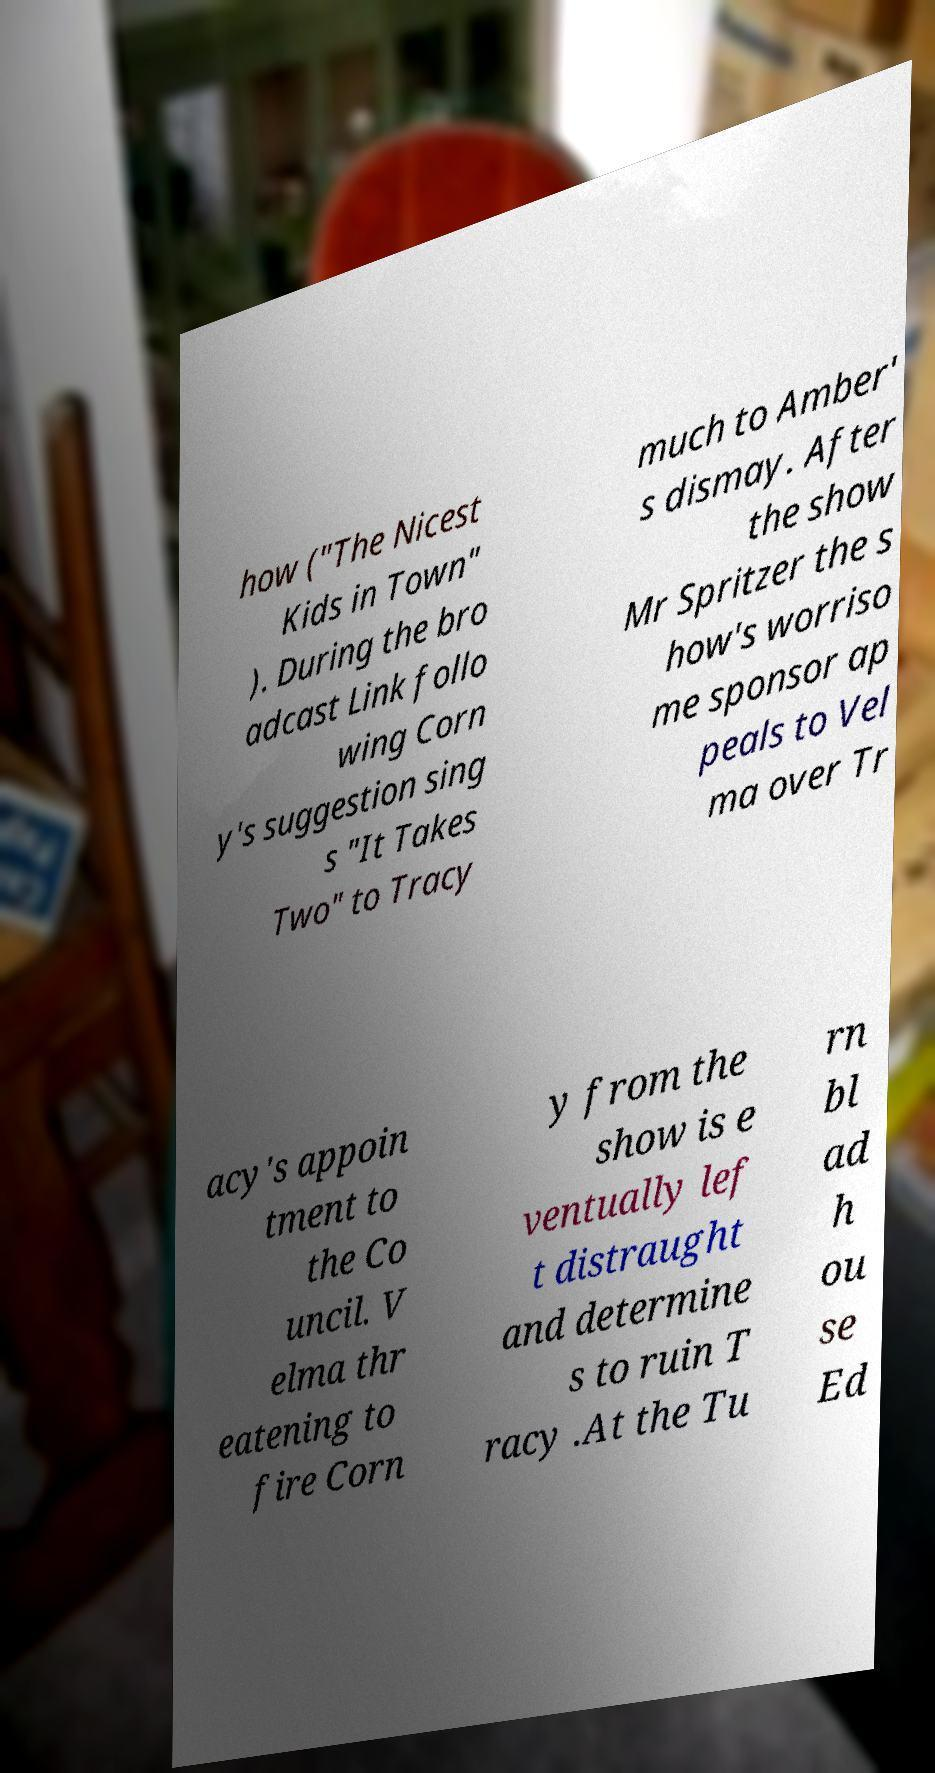There's text embedded in this image that I need extracted. Can you transcribe it verbatim? how ("The Nicest Kids in Town" ). During the bro adcast Link follo wing Corn y's suggestion sing s "It Takes Two" to Tracy much to Amber' s dismay. After the show Mr Spritzer the s how's worriso me sponsor ap peals to Vel ma over Tr acy's appoin tment to the Co uncil. V elma thr eatening to fire Corn y from the show is e ventually lef t distraught and determine s to ruin T racy .At the Tu rn bl ad h ou se Ed 